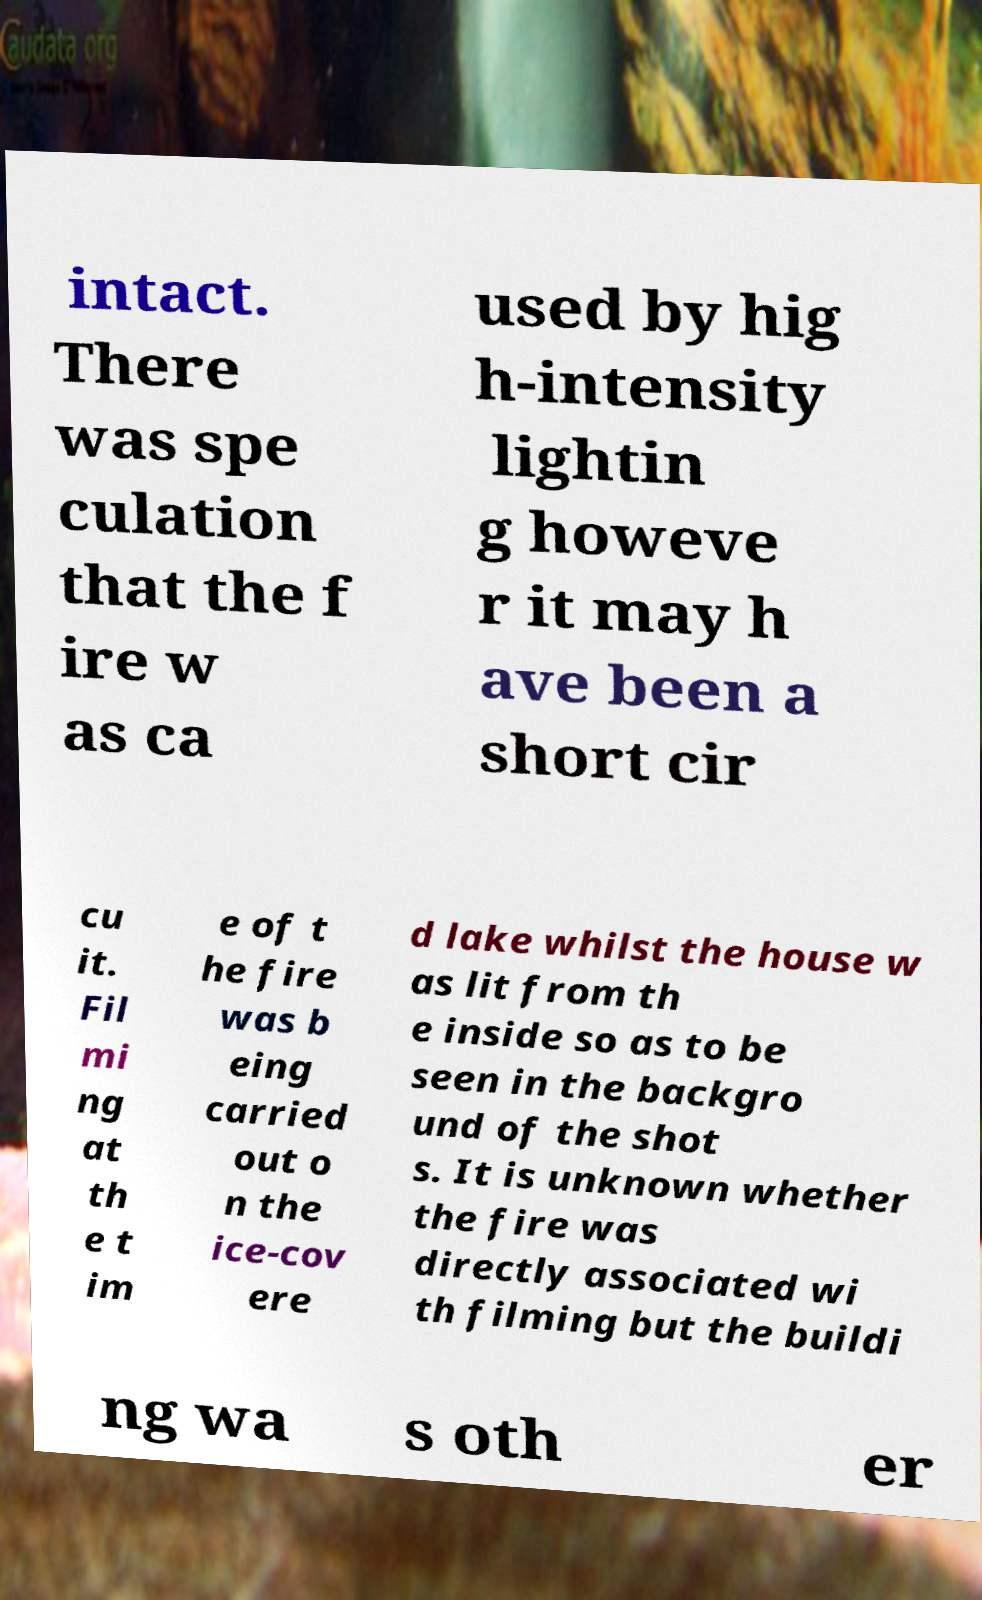Can you accurately transcribe the text from the provided image for me? intact. There was spe culation that the f ire w as ca used by hig h-intensity lightin g howeve r it may h ave been a short cir cu it. Fil mi ng at th e t im e of t he fire was b eing carried out o n the ice-cov ere d lake whilst the house w as lit from th e inside so as to be seen in the backgro und of the shot s. It is unknown whether the fire was directly associated wi th filming but the buildi ng wa s oth er 